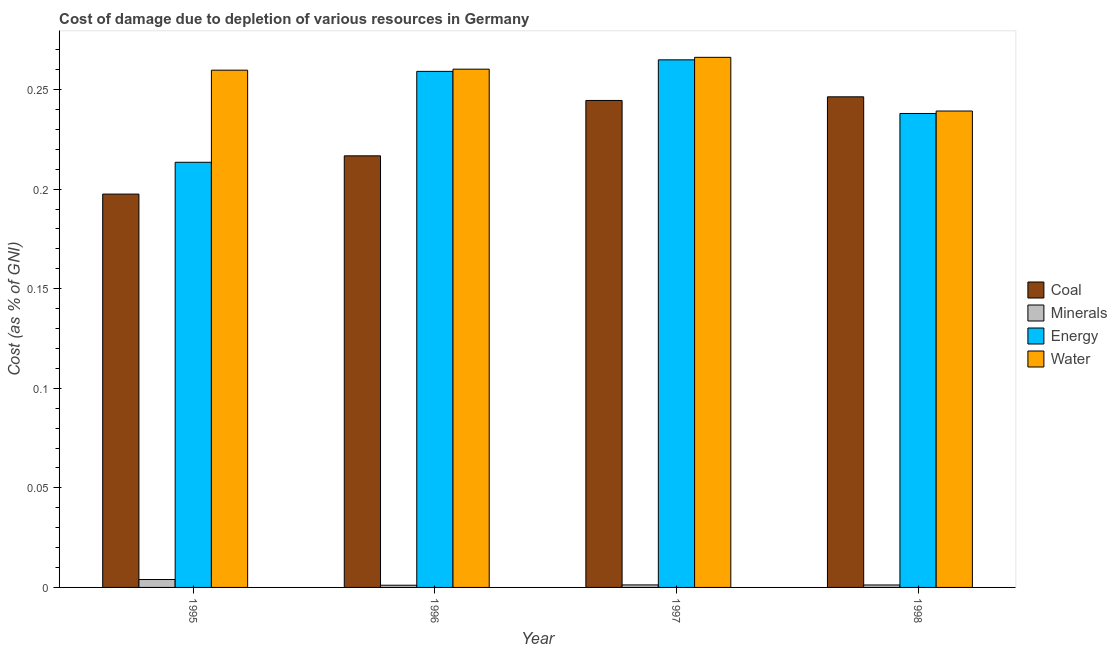How many groups of bars are there?
Keep it short and to the point. 4. Are the number of bars per tick equal to the number of legend labels?
Ensure brevity in your answer.  Yes. Are the number of bars on each tick of the X-axis equal?
Give a very brief answer. Yes. How many bars are there on the 4th tick from the right?
Keep it short and to the point. 4. What is the label of the 3rd group of bars from the left?
Provide a succinct answer. 1997. In how many cases, is the number of bars for a given year not equal to the number of legend labels?
Your response must be concise. 0. What is the cost of damage due to depletion of coal in 1998?
Offer a very short reply. 0.25. Across all years, what is the maximum cost of damage due to depletion of water?
Offer a terse response. 0.27. Across all years, what is the minimum cost of damage due to depletion of minerals?
Give a very brief answer. 0. In which year was the cost of damage due to depletion of coal maximum?
Give a very brief answer. 1998. In which year was the cost of damage due to depletion of coal minimum?
Provide a short and direct response. 1995. What is the total cost of damage due to depletion of water in the graph?
Ensure brevity in your answer.  1.03. What is the difference between the cost of damage due to depletion of energy in 1995 and that in 1998?
Your answer should be compact. -0.02. What is the difference between the cost of damage due to depletion of water in 1997 and the cost of damage due to depletion of minerals in 1998?
Keep it short and to the point. 0.03. What is the average cost of damage due to depletion of water per year?
Provide a short and direct response. 0.26. In the year 1996, what is the difference between the cost of damage due to depletion of coal and cost of damage due to depletion of water?
Ensure brevity in your answer.  0. In how many years, is the cost of damage due to depletion of water greater than 0.060000000000000005 %?
Your answer should be very brief. 4. What is the ratio of the cost of damage due to depletion of water in 1996 to that in 1998?
Offer a terse response. 1.09. Is the cost of damage due to depletion of water in 1995 less than that in 1996?
Ensure brevity in your answer.  Yes. Is the difference between the cost of damage due to depletion of energy in 1995 and 1998 greater than the difference between the cost of damage due to depletion of coal in 1995 and 1998?
Give a very brief answer. No. What is the difference between the highest and the second highest cost of damage due to depletion of water?
Your answer should be compact. 0.01. What is the difference between the highest and the lowest cost of damage due to depletion of energy?
Your answer should be very brief. 0.05. In how many years, is the cost of damage due to depletion of water greater than the average cost of damage due to depletion of water taken over all years?
Your response must be concise. 3. Is the sum of the cost of damage due to depletion of coal in 1995 and 1998 greater than the maximum cost of damage due to depletion of minerals across all years?
Provide a short and direct response. Yes. What does the 4th bar from the left in 1995 represents?
Offer a very short reply. Water. What does the 4th bar from the right in 1996 represents?
Make the answer very short. Coal. Is it the case that in every year, the sum of the cost of damage due to depletion of coal and cost of damage due to depletion of minerals is greater than the cost of damage due to depletion of energy?
Your answer should be compact. No. How many bars are there?
Offer a terse response. 16. How many years are there in the graph?
Ensure brevity in your answer.  4. What is the difference between two consecutive major ticks on the Y-axis?
Provide a succinct answer. 0.05. How are the legend labels stacked?
Provide a short and direct response. Vertical. What is the title of the graph?
Offer a terse response. Cost of damage due to depletion of various resources in Germany . What is the label or title of the X-axis?
Your answer should be very brief. Year. What is the label or title of the Y-axis?
Provide a short and direct response. Cost (as % of GNI). What is the Cost (as % of GNI) in Coal in 1995?
Make the answer very short. 0.2. What is the Cost (as % of GNI) in Minerals in 1995?
Keep it short and to the point. 0. What is the Cost (as % of GNI) of Energy in 1995?
Offer a terse response. 0.21. What is the Cost (as % of GNI) of Water in 1995?
Provide a short and direct response. 0.26. What is the Cost (as % of GNI) of Coal in 1996?
Make the answer very short. 0.22. What is the Cost (as % of GNI) in Minerals in 1996?
Your answer should be compact. 0. What is the Cost (as % of GNI) of Energy in 1996?
Provide a short and direct response. 0.26. What is the Cost (as % of GNI) of Water in 1996?
Provide a succinct answer. 0.26. What is the Cost (as % of GNI) of Coal in 1997?
Keep it short and to the point. 0.24. What is the Cost (as % of GNI) in Minerals in 1997?
Your response must be concise. 0. What is the Cost (as % of GNI) of Energy in 1997?
Offer a terse response. 0.26. What is the Cost (as % of GNI) in Water in 1997?
Your answer should be very brief. 0.27. What is the Cost (as % of GNI) in Coal in 1998?
Give a very brief answer. 0.25. What is the Cost (as % of GNI) in Minerals in 1998?
Provide a short and direct response. 0. What is the Cost (as % of GNI) of Energy in 1998?
Your response must be concise. 0.24. What is the Cost (as % of GNI) of Water in 1998?
Make the answer very short. 0.24. Across all years, what is the maximum Cost (as % of GNI) of Coal?
Your response must be concise. 0.25. Across all years, what is the maximum Cost (as % of GNI) in Minerals?
Give a very brief answer. 0. Across all years, what is the maximum Cost (as % of GNI) in Energy?
Make the answer very short. 0.26. Across all years, what is the maximum Cost (as % of GNI) in Water?
Your answer should be compact. 0.27. Across all years, what is the minimum Cost (as % of GNI) of Coal?
Your answer should be very brief. 0.2. Across all years, what is the minimum Cost (as % of GNI) in Minerals?
Offer a very short reply. 0. Across all years, what is the minimum Cost (as % of GNI) of Energy?
Offer a very short reply. 0.21. Across all years, what is the minimum Cost (as % of GNI) in Water?
Give a very brief answer. 0.24. What is the total Cost (as % of GNI) in Coal in the graph?
Ensure brevity in your answer.  0.91. What is the total Cost (as % of GNI) of Minerals in the graph?
Offer a very short reply. 0.01. What is the total Cost (as % of GNI) of Energy in the graph?
Your response must be concise. 0.98. What is the total Cost (as % of GNI) in Water in the graph?
Keep it short and to the point. 1.03. What is the difference between the Cost (as % of GNI) of Coal in 1995 and that in 1996?
Offer a terse response. -0.02. What is the difference between the Cost (as % of GNI) in Minerals in 1995 and that in 1996?
Keep it short and to the point. 0. What is the difference between the Cost (as % of GNI) in Energy in 1995 and that in 1996?
Provide a succinct answer. -0.05. What is the difference between the Cost (as % of GNI) of Water in 1995 and that in 1996?
Make the answer very short. -0. What is the difference between the Cost (as % of GNI) of Coal in 1995 and that in 1997?
Keep it short and to the point. -0.05. What is the difference between the Cost (as % of GNI) in Minerals in 1995 and that in 1997?
Provide a short and direct response. 0. What is the difference between the Cost (as % of GNI) in Energy in 1995 and that in 1997?
Give a very brief answer. -0.05. What is the difference between the Cost (as % of GNI) in Water in 1995 and that in 1997?
Offer a very short reply. -0.01. What is the difference between the Cost (as % of GNI) of Coal in 1995 and that in 1998?
Your answer should be compact. -0.05. What is the difference between the Cost (as % of GNI) of Minerals in 1995 and that in 1998?
Make the answer very short. 0. What is the difference between the Cost (as % of GNI) of Energy in 1995 and that in 1998?
Ensure brevity in your answer.  -0.02. What is the difference between the Cost (as % of GNI) of Water in 1995 and that in 1998?
Your response must be concise. 0.02. What is the difference between the Cost (as % of GNI) of Coal in 1996 and that in 1997?
Keep it short and to the point. -0.03. What is the difference between the Cost (as % of GNI) of Minerals in 1996 and that in 1997?
Offer a terse response. -0. What is the difference between the Cost (as % of GNI) of Energy in 1996 and that in 1997?
Keep it short and to the point. -0.01. What is the difference between the Cost (as % of GNI) in Water in 1996 and that in 1997?
Your answer should be compact. -0.01. What is the difference between the Cost (as % of GNI) in Coal in 1996 and that in 1998?
Provide a short and direct response. -0.03. What is the difference between the Cost (as % of GNI) of Minerals in 1996 and that in 1998?
Provide a short and direct response. -0. What is the difference between the Cost (as % of GNI) in Energy in 1996 and that in 1998?
Provide a succinct answer. 0.02. What is the difference between the Cost (as % of GNI) in Water in 1996 and that in 1998?
Your response must be concise. 0.02. What is the difference between the Cost (as % of GNI) of Coal in 1997 and that in 1998?
Give a very brief answer. -0. What is the difference between the Cost (as % of GNI) of Minerals in 1997 and that in 1998?
Keep it short and to the point. 0. What is the difference between the Cost (as % of GNI) in Energy in 1997 and that in 1998?
Keep it short and to the point. 0.03. What is the difference between the Cost (as % of GNI) in Water in 1997 and that in 1998?
Keep it short and to the point. 0.03. What is the difference between the Cost (as % of GNI) in Coal in 1995 and the Cost (as % of GNI) in Minerals in 1996?
Your answer should be very brief. 0.2. What is the difference between the Cost (as % of GNI) of Coal in 1995 and the Cost (as % of GNI) of Energy in 1996?
Your answer should be compact. -0.06. What is the difference between the Cost (as % of GNI) in Coal in 1995 and the Cost (as % of GNI) in Water in 1996?
Provide a succinct answer. -0.06. What is the difference between the Cost (as % of GNI) in Minerals in 1995 and the Cost (as % of GNI) in Energy in 1996?
Make the answer very short. -0.26. What is the difference between the Cost (as % of GNI) in Minerals in 1995 and the Cost (as % of GNI) in Water in 1996?
Keep it short and to the point. -0.26. What is the difference between the Cost (as % of GNI) in Energy in 1995 and the Cost (as % of GNI) in Water in 1996?
Your answer should be compact. -0.05. What is the difference between the Cost (as % of GNI) of Coal in 1995 and the Cost (as % of GNI) of Minerals in 1997?
Your response must be concise. 0.2. What is the difference between the Cost (as % of GNI) in Coal in 1995 and the Cost (as % of GNI) in Energy in 1997?
Provide a short and direct response. -0.07. What is the difference between the Cost (as % of GNI) in Coal in 1995 and the Cost (as % of GNI) in Water in 1997?
Offer a terse response. -0.07. What is the difference between the Cost (as % of GNI) of Minerals in 1995 and the Cost (as % of GNI) of Energy in 1997?
Give a very brief answer. -0.26. What is the difference between the Cost (as % of GNI) in Minerals in 1995 and the Cost (as % of GNI) in Water in 1997?
Offer a very short reply. -0.26. What is the difference between the Cost (as % of GNI) of Energy in 1995 and the Cost (as % of GNI) of Water in 1997?
Provide a succinct answer. -0.05. What is the difference between the Cost (as % of GNI) of Coal in 1995 and the Cost (as % of GNI) of Minerals in 1998?
Keep it short and to the point. 0.2. What is the difference between the Cost (as % of GNI) in Coal in 1995 and the Cost (as % of GNI) in Energy in 1998?
Offer a very short reply. -0.04. What is the difference between the Cost (as % of GNI) of Coal in 1995 and the Cost (as % of GNI) of Water in 1998?
Provide a short and direct response. -0.04. What is the difference between the Cost (as % of GNI) of Minerals in 1995 and the Cost (as % of GNI) of Energy in 1998?
Your answer should be compact. -0.23. What is the difference between the Cost (as % of GNI) in Minerals in 1995 and the Cost (as % of GNI) in Water in 1998?
Provide a short and direct response. -0.24. What is the difference between the Cost (as % of GNI) of Energy in 1995 and the Cost (as % of GNI) of Water in 1998?
Offer a terse response. -0.03. What is the difference between the Cost (as % of GNI) in Coal in 1996 and the Cost (as % of GNI) in Minerals in 1997?
Give a very brief answer. 0.22. What is the difference between the Cost (as % of GNI) of Coal in 1996 and the Cost (as % of GNI) of Energy in 1997?
Keep it short and to the point. -0.05. What is the difference between the Cost (as % of GNI) in Coal in 1996 and the Cost (as % of GNI) in Water in 1997?
Provide a succinct answer. -0.05. What is the difference between the Cost (as % of GNI) of Minerals in 1996 and the Cost (as % of GNI) of Energy in 1997?
Your response must be concise. -0.26. What is the difference between the Cost (as % of GNI) in Minerals in 1996 and the Cost (as % of GNI) in Water in 1997?
Your answer should be compact. -0.27. What is the difference between the Cost (as % of GNI) of Energy in 1996 and the Cost (as % of GNI) of Water in 1997?
Your answer should be compact. -0.01. What is the difference between the Cost (as % of GNI) of Coal in 1996 and the Cost (as % of GNI) of Minerals in 1998?
Provide a succinct answer. 0.22. What is the difference between the Cost (as % of GNI) of Coal in 1996 and the Cost (as % of GNI) of Energy in 1998?
Offer a terse response. -0.02. What is the difference between the Cost (as % of GNI) of Coal in 1996 and the Cost (as % of GNI) of Water in 1998?
Your response must be concise. -0.02. What is the difference between the Cost (as % of GNI) of Minerals in 1996 and the Cost (as % of GNI) of Energy in 1998?
Ensure brevity in your answer.  -0.24. What is the difference between the Cost (as % of GNI) in Minerals in 1996 and the Cost (as % of GNI) in Water in 1998?
Provide a succinct answer. -0.24. What is the difference between the Cost (as % of GNI) of Energy in 1996 and the Cost (as % of GNI) of Water in 1998?
Ensure brevity in your answer.  0.02. What is the difference between the Cost (as % of GNI) in Coal in 1997 and the Cost (as % of GNI) in Minerals in 1998?
Provide a short and direct response. 0.24. What is the difference between the Cost (as % of GNI) of Coal in 1997 and the Cost (as % of GNI) of Energy in 1998?
Ensure brevity in your answer.  0.01. What is the difference between the Cost (as % of GNI) of Coal in 1997 and the Cost (as % of GNI) of Water in 1998?
Provide a short and direct response. 0.01. What is the difference between the Cost (as % of GNI) of Minerals in 1997 and the Cost (as % of GNI) of Energy in 1998?
Your response must be concise. -0.24. What is the difference between the Cost (as % of GNI) of Minerals in 1997 and the Cost (as % of GNI) of Water in 1998?
Make the answer very short. -0.24. What is the difference between the Cost (as % of GNI) in Energy in 1997 and the Cost (as % of GNI) in Water in 1998?
Provide a succinct answer. 0.03. What is the average Cost (as % of GNI) of Coal per year?
Your answer should be very brief. 0.23. What is the average Cost (as % of GNI) in Minerals per year?
Provide a short and direct response. 0. What is the average Cost (as % of GNI) of Energy per year?
Offer a terse response. 0.24. What is the average Cost (as % of GNI) of Water per year?
Make the answer very short. 0.26. In the year 1995, what is the difference between the Cost (as % of GNI) in Coal and Cost (as % of GNI) in Minerals?
Your response must be concise. 0.19. In the year 1995, what is the difference between the Cost (as % of GNI) of Coal and Cost (as % of GNI) of Energy?
Provide a short and direct response. -0.02. In the year 1995, what is the difference between the Cost (as % of GNI) in Coal and Cost (as % of GNI) in Water?
Make the answer very short. -0.06. In the year 1995, what is the difference between the Cost (as % of GNI) of Minerals and Cost (as % of GNI) of Energy?
Ensure brevity in your answer.  -0.21. In the year 1995, what is the difference between the Cost (as % of GNI) of Minerals and Cost (as % of GNI) of Water?
Your response must be concise. -0.26. In the year 1995, what is the difference between the Cost (as % of GNI) in Energy and Cost (as % of GNI) in Water?
Provide a short and direct response. -0.05. In the year 1996, what is the difference between the Cost (as % of GNI) of Coal and Cost (as % of GNI) of Minerals?
Offer a very short reply. 0.22. In the year 1996, what is the difference between the Cost (as % of GNI) of Coal and Cost (as % of GNI) of Energy?
Keep it short and to the point. -0.04. In the year 1996, what is the difference between the Cost (as % of GNI) in Coal and Cost (as % of GNI) in Water?
Your response must be concise. -0.04. In the year 1996, what is the difference between the Cost (as % of GNI) of Minerals and Cost (as % of GNI) of Energy?
Keep it short and to the point. -0.26. In the year 1996, what is the difference between the Cost (as % of GNI) in Minerals and Cost (as % of GNI) in Water?
Give a very brief answer. -0.26. In the year 1996, what is the difference between the Cost (as % of GNI) of Energy and Cost (as % of GNI) of Water?
Provide a short and direct response. -0. In the year 1997, what is the difference between the Cost (as % of GNI) in Coal and Cost (as % of GNI) in Minerals?
Your answer should be compact. 0.24. In the year 1997, what is the difference between the Cost (as % of GNI) in Coal and Cost (as % of GNI) in Energy?
Offer a very short reply. -0.02. In the year 1997, what is the difference between the Cost (as % of GNI) of Coal and Cost (as % of GNI) of Water?
Your answer should be very brief. -0.02. In the year 1997, what is the difference between the Cost (as % of GNI) in Minerals and Cost (as % of GNI) in Energy?
Ensure brevity in your answer.  -0.26. In the year 1997, what is the difference between the Cost (as % of GNI) of Minerals and Cost (as % of GNI) of Water?
Provide a short and direct response. -0.26. In the year 1997, what is the difference between the Cost (as % of GNI) of Energy and Cost (as % of GNI) of Water?
Your answer should be compact. -0. In the year 1998, what is the difference between the Cost (as % of GNI) in Coal and Cost (as % of GNI) in Minerals?
Provide a short and direct response. 0.25. In the year 1998, what is the difference between the Cost (as % of GNI) in Coal and Cost (as % of GNI) in Energy?
Your response must be concise. 0.01. In the year 1998, what is the difference between the Cost (as % of GNI) of Coal and Cost (as % of GNI) of Water?
Your answer should be very brief. 0.01. In the year 1998, what is the difference between the Cost (as % of GNI) in Minerals and Cost (as % of GNI) in Energy?
Provide a succinct answer. -0.24. In the year 1998, what is the difference between the Cost (as % of GNI) of Minerals and Cost (as % of GNI) of Water?
Your response must be concise. -0.24. In the year 1998, what is the difference between the Cost (as % of GNI) in Energy and Cost (as % of GNI) in Water?
Offer a terse response. -0. What is the ratio of the Cost (as % of GNI) of Coal in 1995 to that in 1996?
Make the answer very short. 0.91. What is the ratio of the Cost (as % of GNI) in Minerals in 1995 to that in 1996?
Offer a terse response. 3.59. What is the ratio of the Cost (as % of GNI) of Energy in 1995 to that in 1996?
Offer a terse response. 0.82. What is the ratio of the Cost (as % of GNI) of Coal in 1995 to that in 1997?
Your response must be concise. 0.81. What is the ratio of the Cost (as % of GNI) in Minerals in 1995 to that in 1997?
Offer a terse response. 3.14. What is the ratio of the Cost (as % of GNI) in Energy in 1995 to that in 1997?
Give a very brief answer. 0.81. What is the ratio of the Cost (as % of GNI) of Water in 1995 to that in 1997?
Ensure brevity in your answer.  0.98. What is the ratio of the Cost (as % of GNI) in Coal in 1995 to that in 1998?
Provide a short and direct response. 0.8. What is the ratio of the Cost (as % of GNI) in Minerals in 1995 to that in 1998?
Make the answer very short. 3.22. What is the ratio of the Cost (as % of GNI) in Energy in 1995 to that in 1998?
Your answer should be compact. 0.9. What is the ratio of the Cost (as % of GNI) in Water in 1995 to that in 1998?
Make the answer very short. 1.09. What is the ratio of the Cost (as % of GNI) in Coal in 1996 to that in 1997?
Your answer should be compact. 0.89. What is the ratio of the Cost (as % of GNI) of Minerals in 1996 to that in 1997?
Provide a succinct answer. 0.88. What is the ratio of the Cost (as % of GNI) of Energy in 1996 to that in 1997?
Your answer should be very brief. 0.98. What is the ratio of the Cost (as % of GNI) in Water in 1996 to that in 1997?
Give a very brief answer. 0.98. What is the ratio of the Cost (as % of GNI) of Coal in 1996 to that in 1998?
Give a very brief answer. 0.88. What is the ratio of the Cost (as % of GNI) of Minerals in 1996 to that in 1998?
Keep it short and to the point. 0.9. What is the ratio of the Cost (as % of GNI) in Energy in 1996 to that in 1998?
Give a very brief answer. 1.09. What is the ratio of the Cost (as % of GNI) in Water in 1996 to that in 1998?
Provide a succinct answer. 1.09. What is the ratio of the Cost (as % of GNI) of Coal in 1997 to that in 1998?
Your answer should be compact. 0.99. What is the ratio of the Cost (as % of GNI) of Minerals in 1997 to that in 1998?
Provide a succinct answer. 1.02. What is the ratio of the Cost (as % of GNI) of Energy in 1997 to that in 1998?
Your answer should be very brief. 1.11. What is the ratio of the Cost (as % of GNI) of Water in 1997 to that in 1998?
Make the answer very short. 1.11. What is the difference between the highest and the second highest Cost (as % of GNI) of Coal?
Provide a short and direct response. 0. What is the difference between the highest and the second highest Cost (as % of GNI) in Minerals?
Your response must be concise. 0. What is the difference between the highest and the second highest Cost (as % of GNI) of Energy?
Keep it short and to the point. 0.01. What is the difference between the highest and the second highest Cost (as % of GNI) of Water?
Your answer should be very brief. 0.01. What is the difference between the highest and the lowest Cost (as % of GNI) in Coal?
Ensure brevity in your answer.  0.05. What is the difference between the highest and the lowest Cost (as % of GNI) of Minerals?
Your answer should be compact. 0. What is the difference between the highest and the lowest Cost (as % of GNI) of Energy?
Give a very brief answer. 0.05. What is the difference between the highest and the lowest Cost (as % of GNI) in Water?
Offer a terse response. 0.03. 